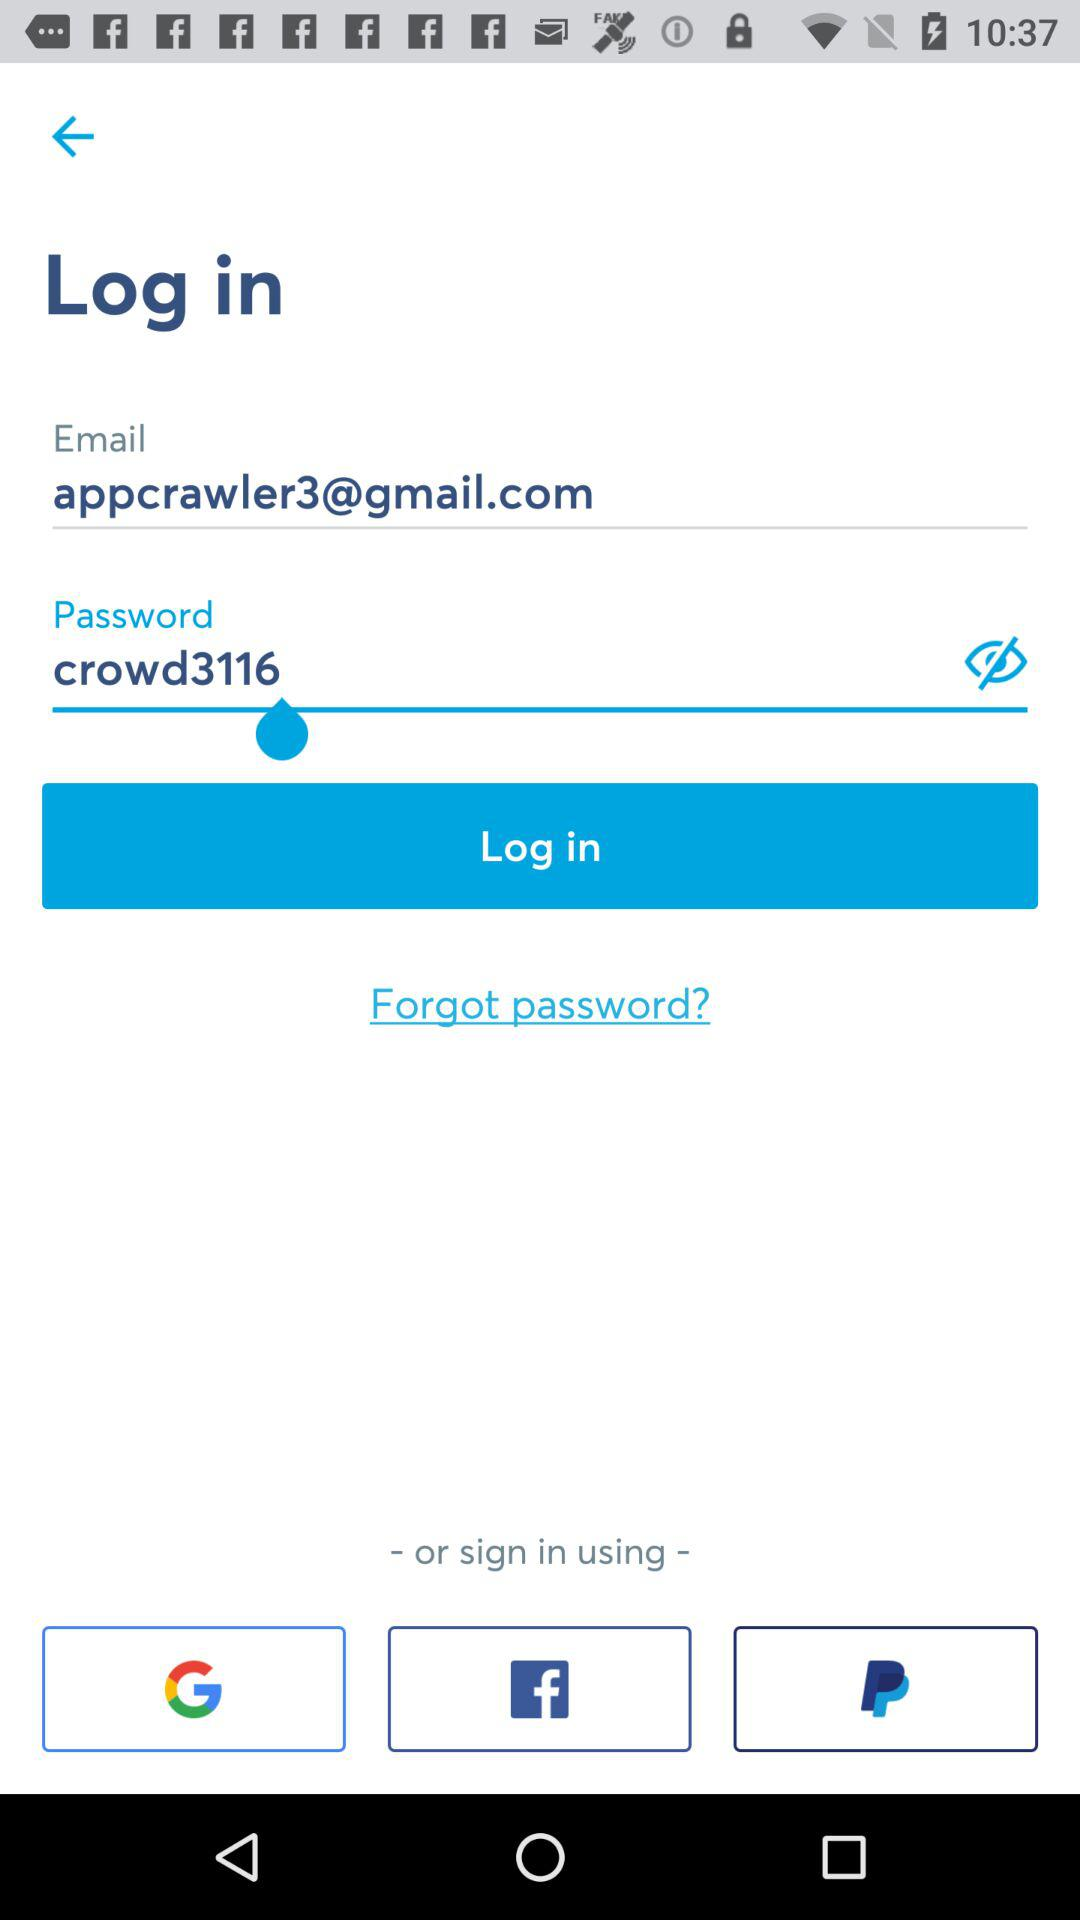What is the email address? The email address is appcrawler3@gmail.com. 